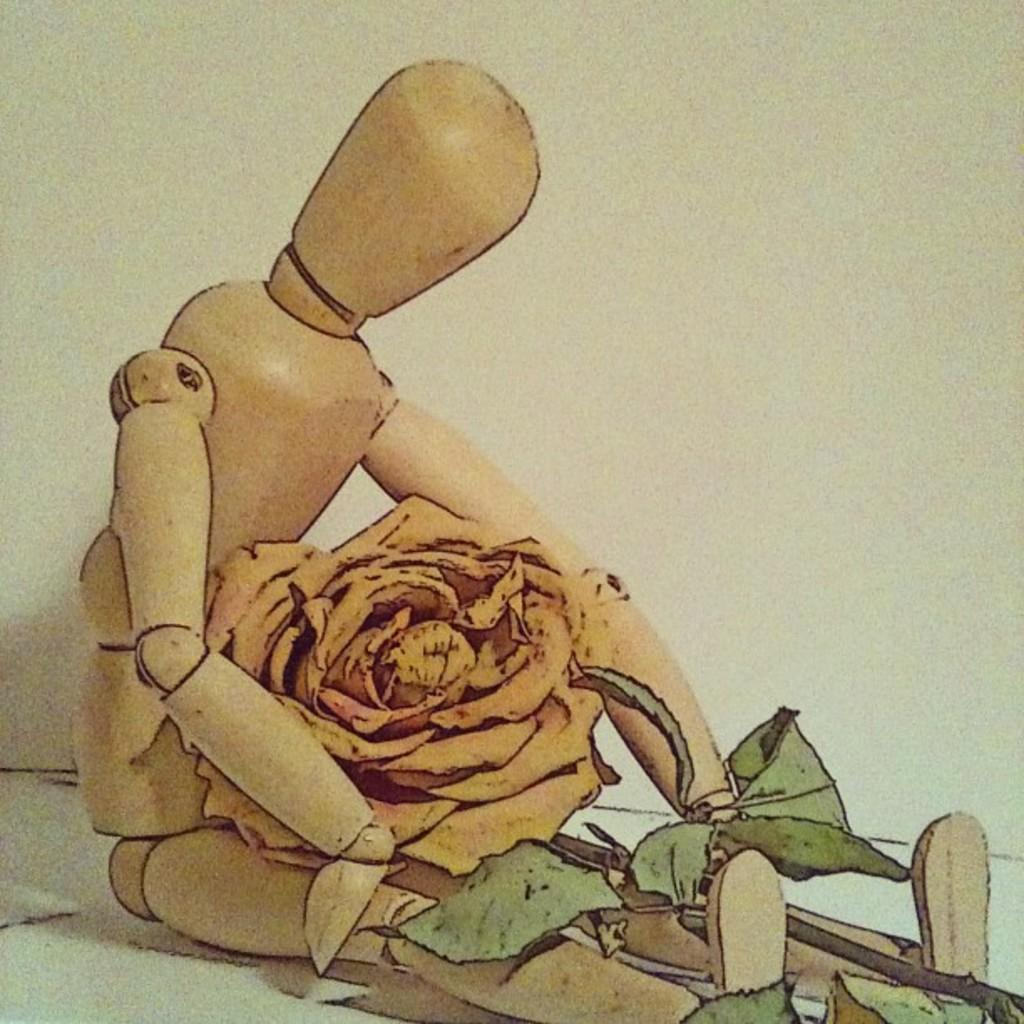What type of toy is in the image? There is a robot toy in the image. What other object is in the image besides the robot toy? There is a rose in the image. What color is the background of the image? The background of the image is white. What can be observed about the rose in the image? The rose has green leaves. What type of ring can be seen on the robot toy's finger in the image? There is no ring present on the robot toy's finger in the image. 